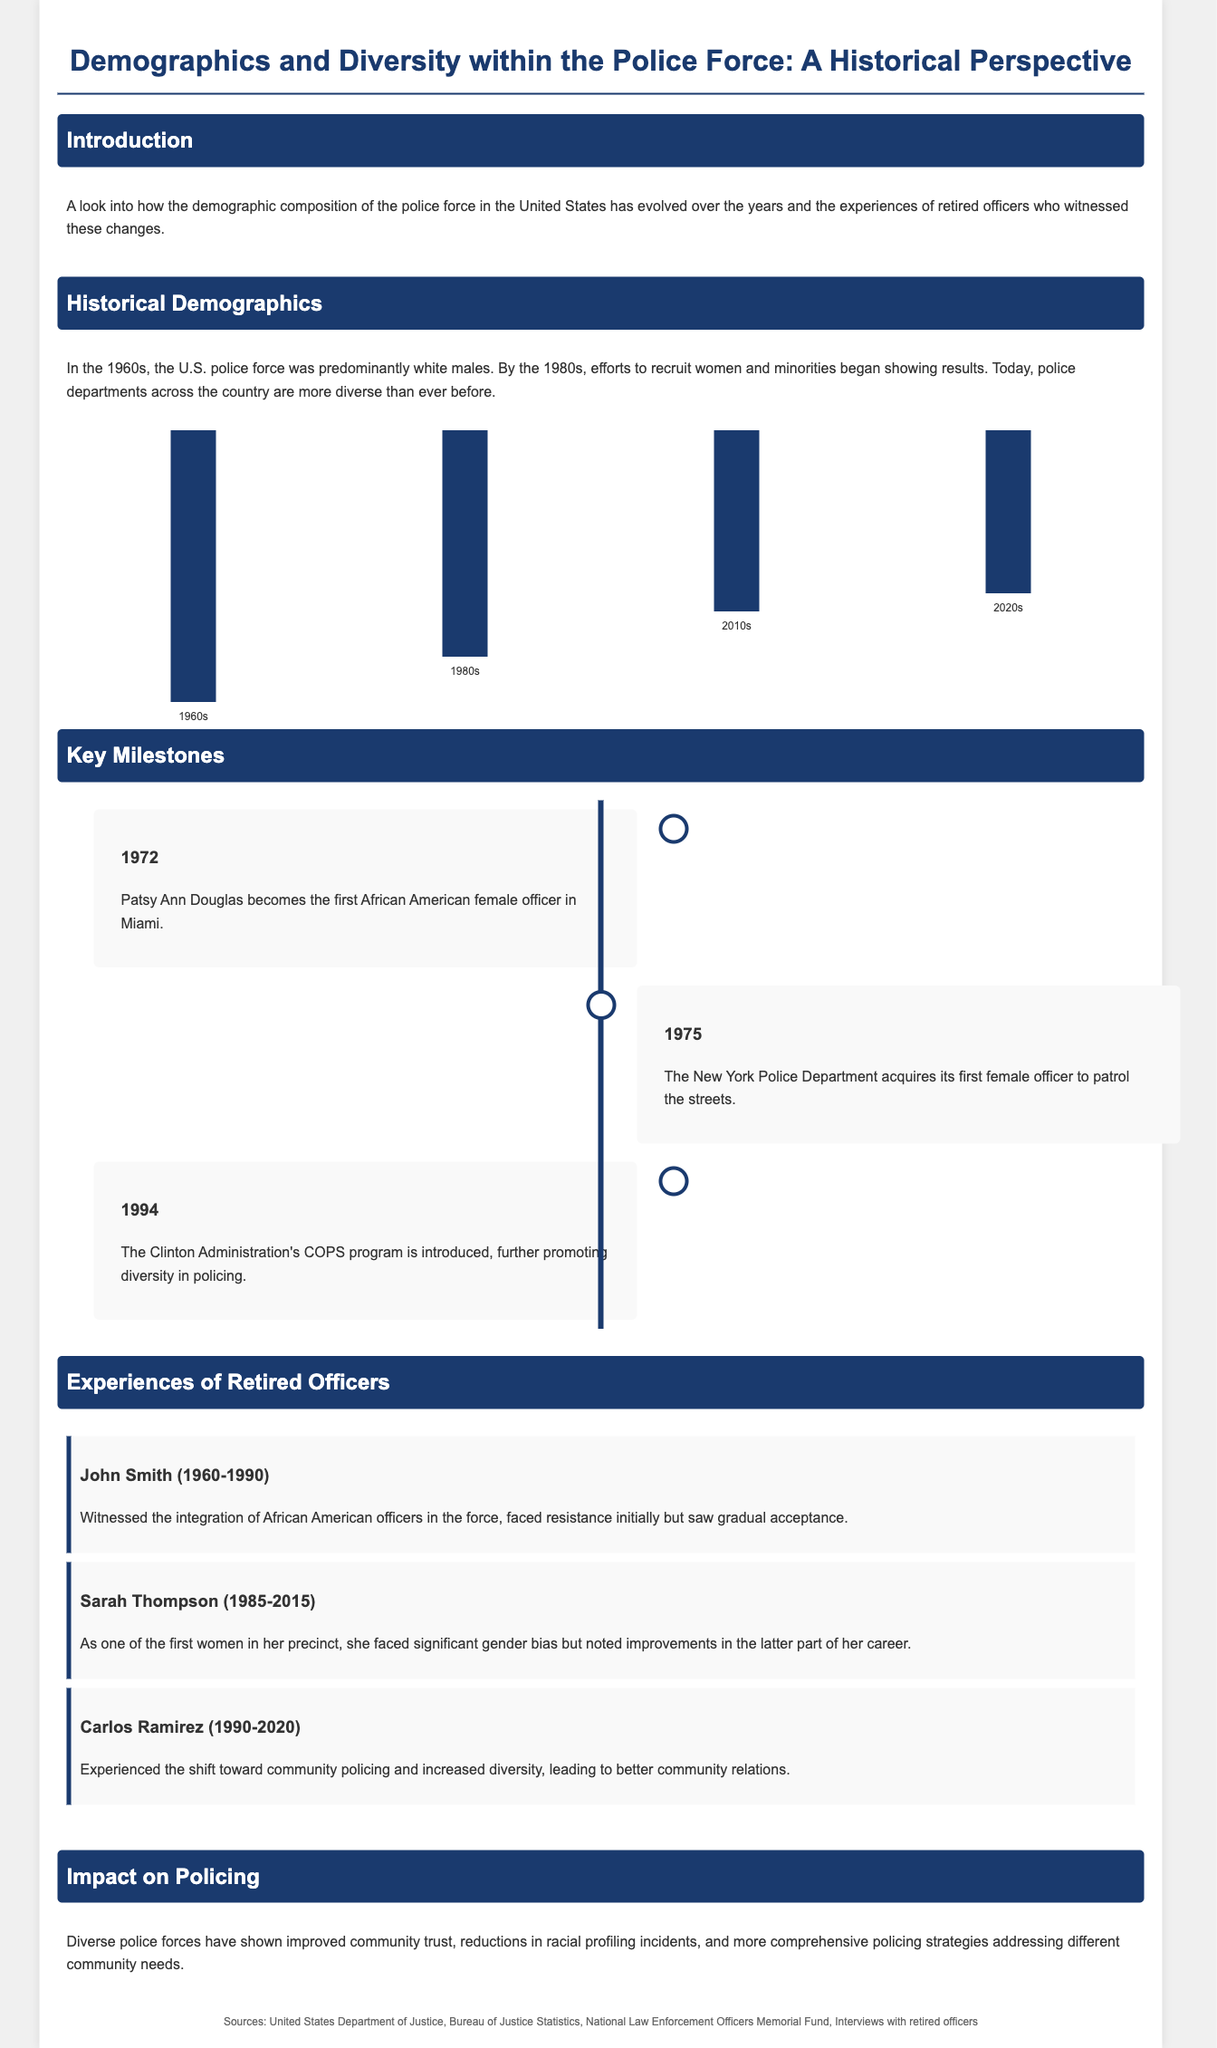what was the demographic composition of the police force in the 1960s? The document states that the U.S. police force was predominantly white males during the 1960s.
Answer: predominantly white males when did Patsy Ann Douglas become the first African American female officer in Miami? The document indicates that Patsy Ann Douglas became the first African American female officer in 1972.
Answer: 1972 what significant program was introduced in 1994 to promote diversity in policing? The document mentions that the Clinton Administration's COPS program was introduced in 1994.
Answer: COPS program how did John Smith describe the integration of African American officers? According to the document, John Smith faced resistance initially but saw gradual acceptance.
Answer: gradual acceptance what has been the impact of diverse police forces on community trust? The document states that diverse police forces have shown improved community trust.
Answer: improved community trust how many years did Sarah Thompson serve in her precinct? The document notes that Sarah Thompson served from 1985 to 2015, which is 30 years.
Answer: 30 years what does the timeline in the document illustrate? The timeline illustrates key milestones in demographic changes within the police force.
Answer: key milestones what was the height of the bar for the 1980s in the historical demographics section? The document shows that the height of the bar for the 1980s is 250 pixels.
Answer: 250 pixels which demographic group saw significant recruitment efforts beginning in the 1980s? The document highlights that efforts to recruit women and minorities began in the 1980s.
Answer: women and minorities 